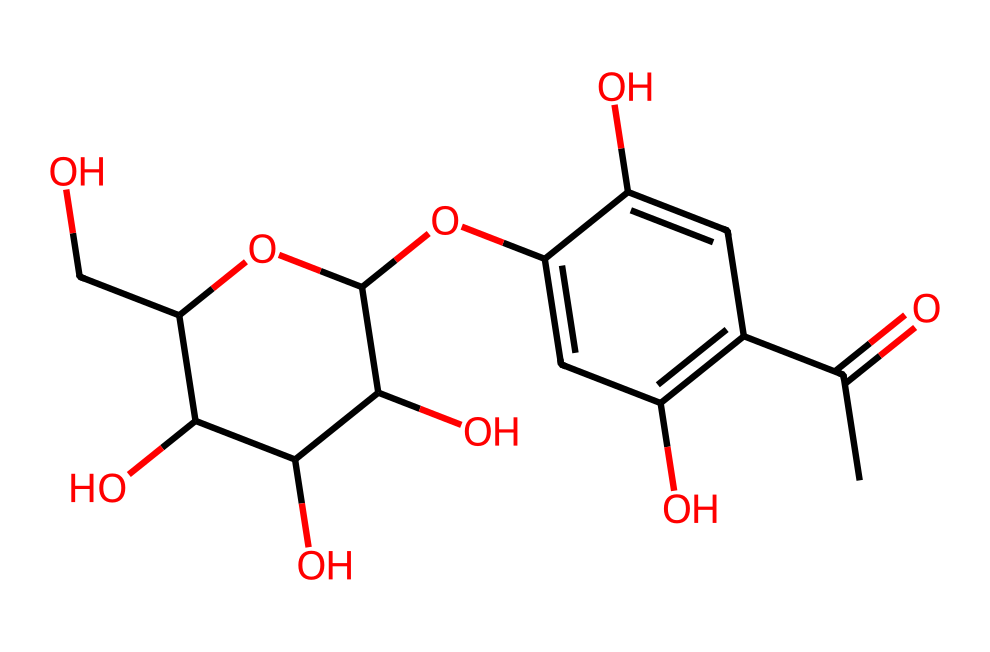How many carbon atoms are in the magical colorful juice? By examining the SMILES representation, we can count the carbon atoms. The portion "CC(=O)" indicates two carbons right away; further along in the structure, there are additional carbons in the ring and side groups. In total, there are ten carbon atoms represented in this molecule.
Answer: ten What functional group is indicated by "C(=O)" in the structure? The "C(=O)" signifies a carbon atom double-bonded to an oxygen atom, which is characteristic of a carbonyl group. This functional group plays a vital role in the chemical properties of the juice.
Answer: carbonyl How many hydroxyl (–OH) groups can be found in the chemical structure? Looking for hydroxyl groups involves identifying each "C" that is directly attached to an "O" without a double bond. In the SMILES, there are four hydroxyl groups present in the structure.
Answer: four What kind of flavor might be associated with this magical juice based on its structure? Analyzing the presence of numerous hydroxyl groups and functional characteristics often corresponds to sweet tastes, suggesting that this juice might have a sweet flavor. Additionally, the esters and sugars contribute to the overall taste profile of fruity drinks.
Answer: sweet Is the magical colorful juice typically soluble in water? Given that the chemical has multiple hydroxyl groups (which are polar), it suggests a good ability to interact with water molecules due to hydrogen bonding. This polar nature usually leads to solubility in water.
Answer: yes 